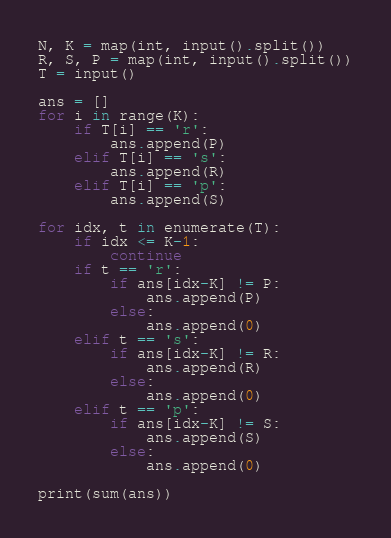<code> <loc_0><loc_0><loc_500><loc_500><_Python_>N, K = map(int, input().split())
R, S, P = map(int, input().split())
T = input()

ans = []
for i in range(K):
    if T[i] == 'r':
        ans.append(P)
    elif T[i] == 's':
        ans.append(R)
    elif T[i] == 'p':
        ans.append(S)

for idx, t in enumerate(T):
    if idx <= K-1:
        continue
    if t == 'r':
        if ans[idx-K] != P:
            ans.append(P)
        else:
            ans.append(0)
    elif t == 's':
        if ans[idx-K] != R:
            ans.append(R)
        else:
            ans.append(0)
    elif t == 'p':
        if ans[idx-K] != S:
            ans.append(S)
        else:
            ans.append(0)
    
print(sum(ans))</code> 